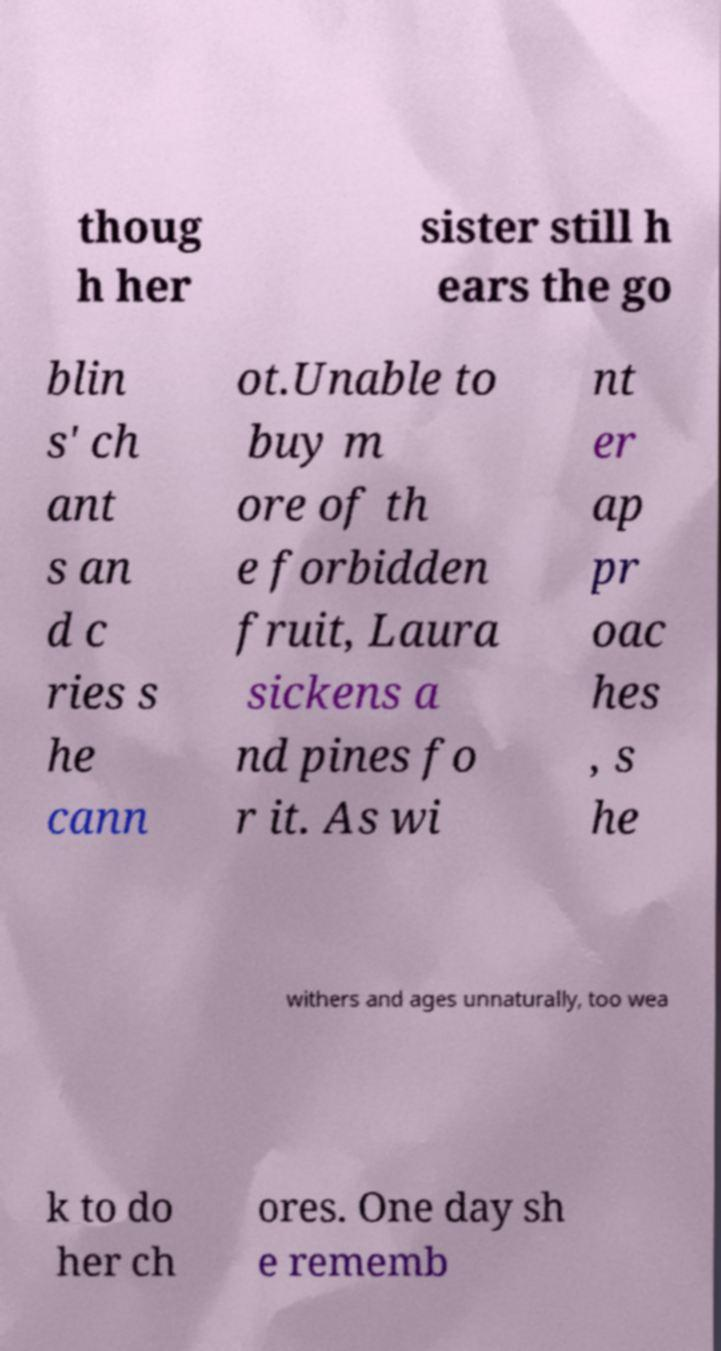Please read and relay the text visible in this image. What does it say? thoug h her sister still h ears the go blin s' ch ant s an d c ries s he cann ot.Unable to buy m ore of th e forbidden fruit, Laura sickens a nd pines fo r it. As wi nt er ap pr oac hes , s he withers and ages unnaturally, too wea k to do her ch ores. One day sh e rememb 